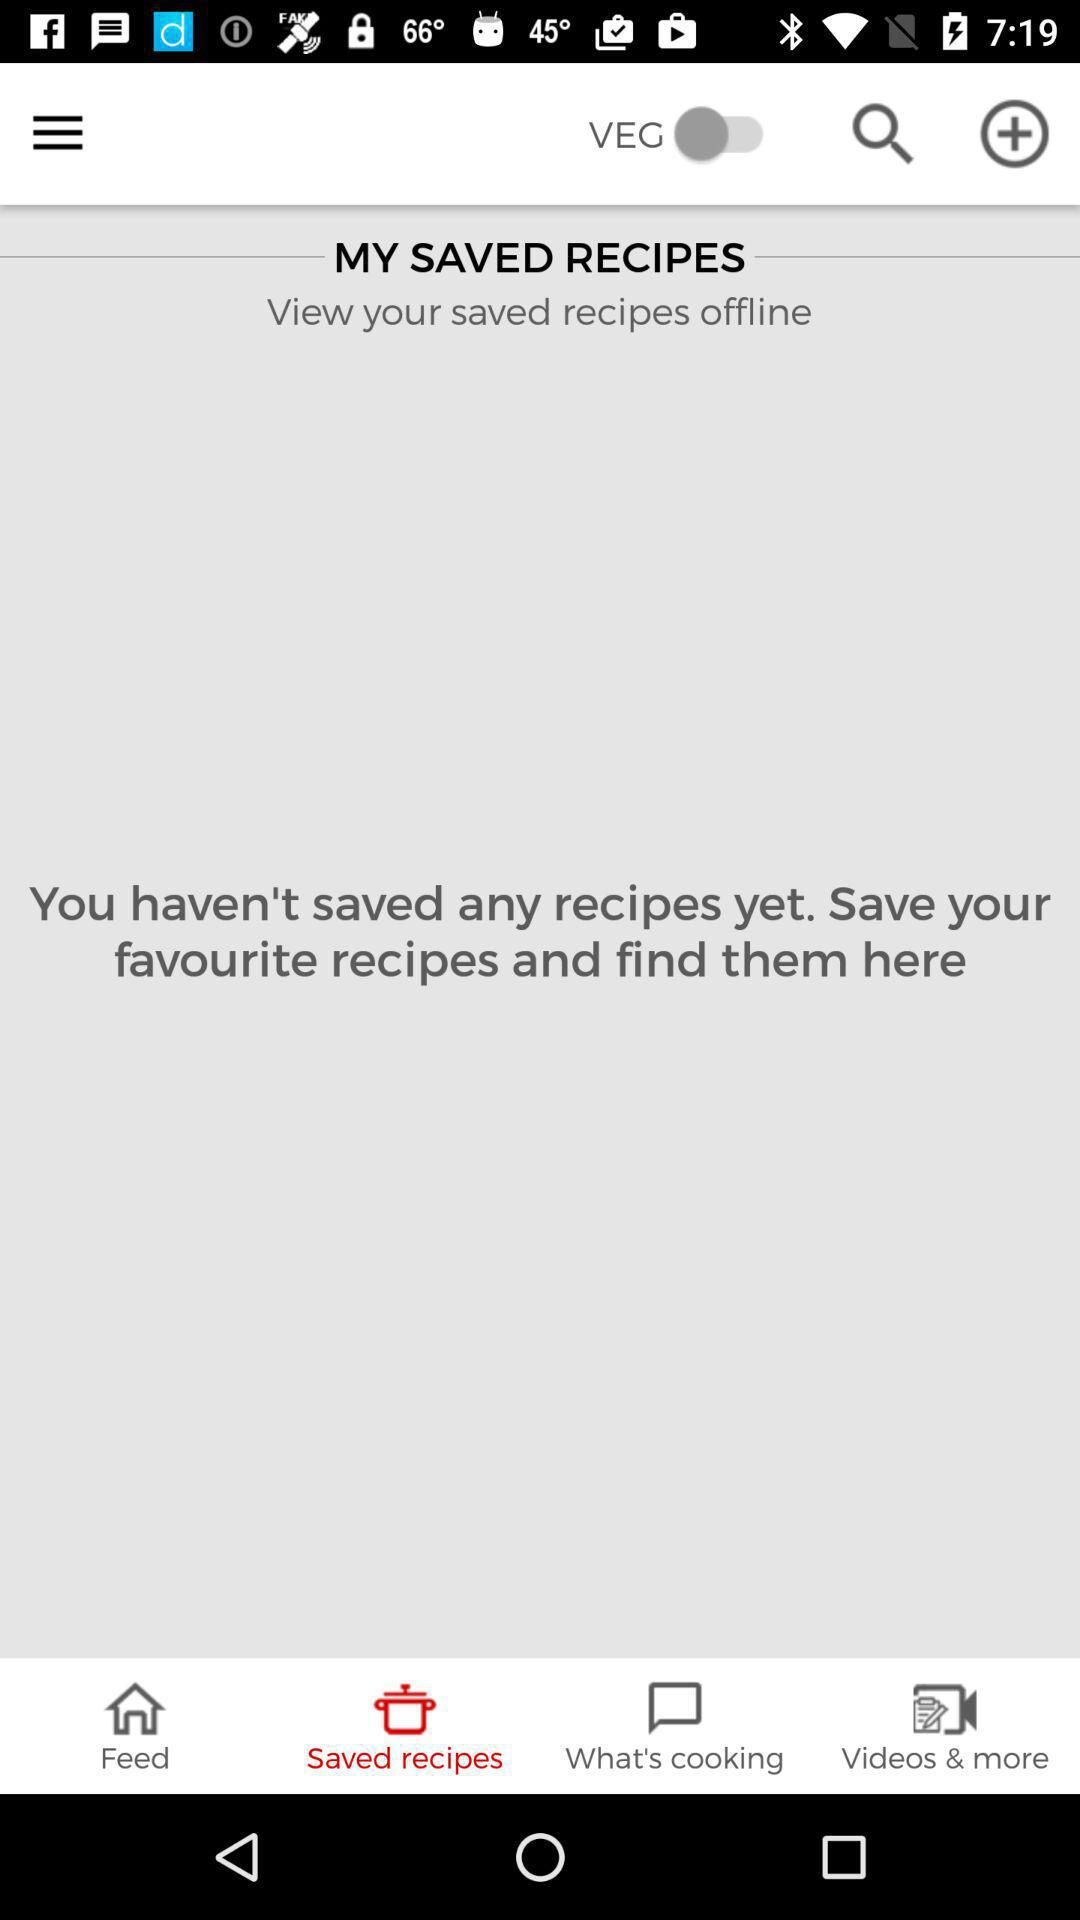How many recipes are saved? You haven't saved any recipes yet. 